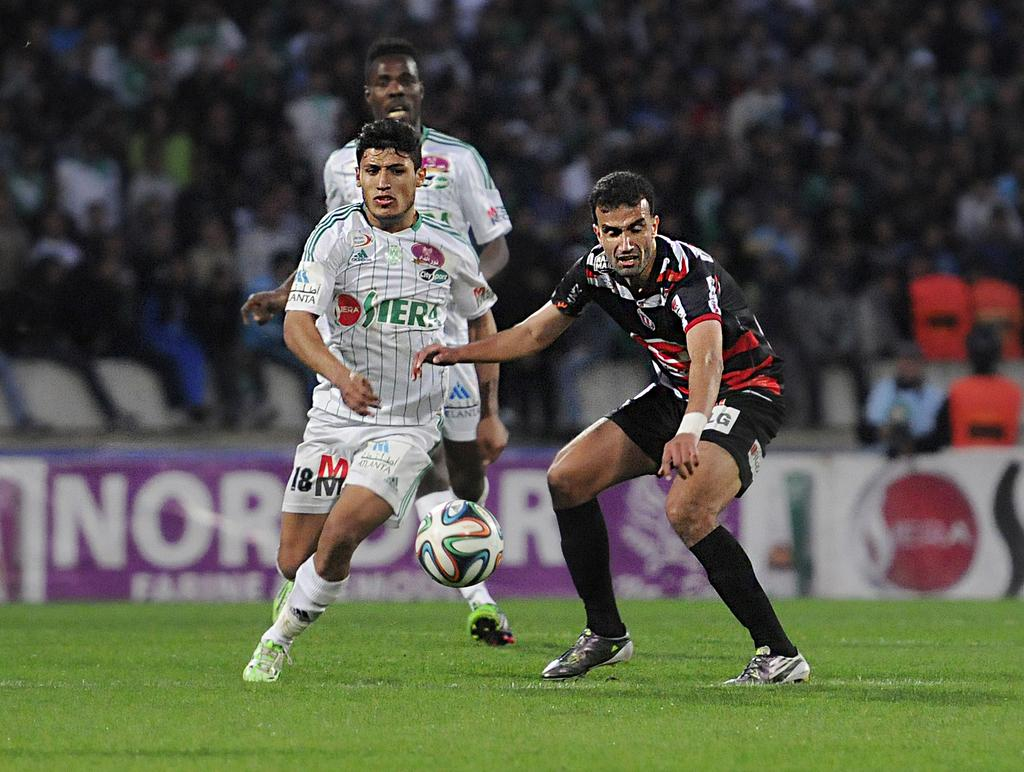What type of surface is the ground covered with in the image? There is grass on the ground in the image. What activity are the three men engaged in? The three men are playing football in the image. Can you describe the people in the background of the image? There is an audience in the background of the image, and they are sitting and watching the game. What type of current is flowing through the football in the image? There is no current flowing through the football in the image; it is a regular football used for playing the game. 